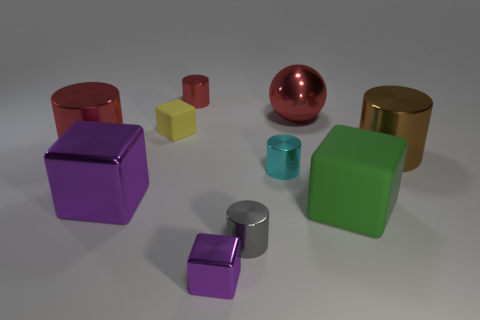Are there any shiny objects to the right of the metallic block left of the rubber block on the left side of the cyan metal object?
Keep it short and to the point. Yes. What material is the brown object?
Your response must be concise. Metal. What number of other things are there of the same shape as the tiny purple shiny thing?
Provide a short and direct response. 3. Does the tiny red thing have the same shape as the small gray thing?
Your response must be concise. Yes. What number of objects are either matte cubes that are on the right side of the small yellow cube or small cylinders that are in front of the big green cube?
Offer a very short reply. 2. What number of objects are either tiny red spheres or small yellow blocks?
Give a very brief answer. 1. There is a red metal thing on the left side of the big purple metal block; what number of yellow objects are in front of it?
Provide a succinct answer. 0. How many other things are the same size as the gray cylinder?
Provide a short and direct response. 4. There is another metal block that is the same color as the large metallic cube; what size is it?
Provide a succinct answer. Small. There is a big red object that is left of the small cyan cylinder; is its shape the same as the tiny gray thing?
Make the answer very short. Yes. 